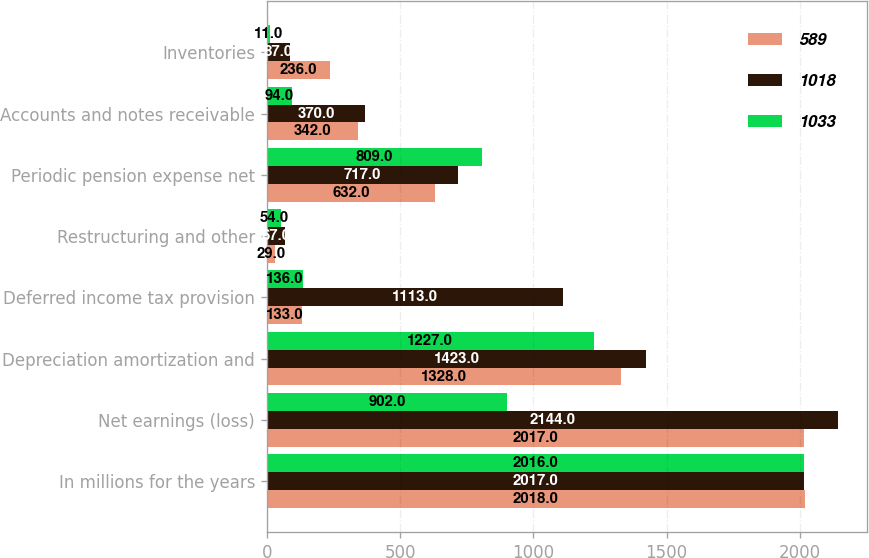Convert chart to OTSL. <chart><loc_0><loc_0><loc_500><loc_500><stacked_bar_chart><ecel><fcel>In millions for the years<fcel>Net earnings (loss)<fcel>Depreciation amortization and<fcel>Deferred income tax provision<fcel>Restructuring and other<fcel>Periodic pension expense net<fcel>Accounts and notes receivable<fcel>Inventories<nl><fcel>589<fcel>2018<fcel>2017<fcel>1328<fcel>133<fcel>29<fcel>632<fcel>342<fcel>236<nl><fcel>1018<fcel>2017<fcel>2144<fcel>1423<fcel>1113<fcel>67<fcel>717<fcel>370<fcel>87<nl><fcel>1033<fcel>2016<fcel>902<fcel>1227<fcel>136<fcel>54<fcel>809<fcel>94<fcel>11<nl></chart> 